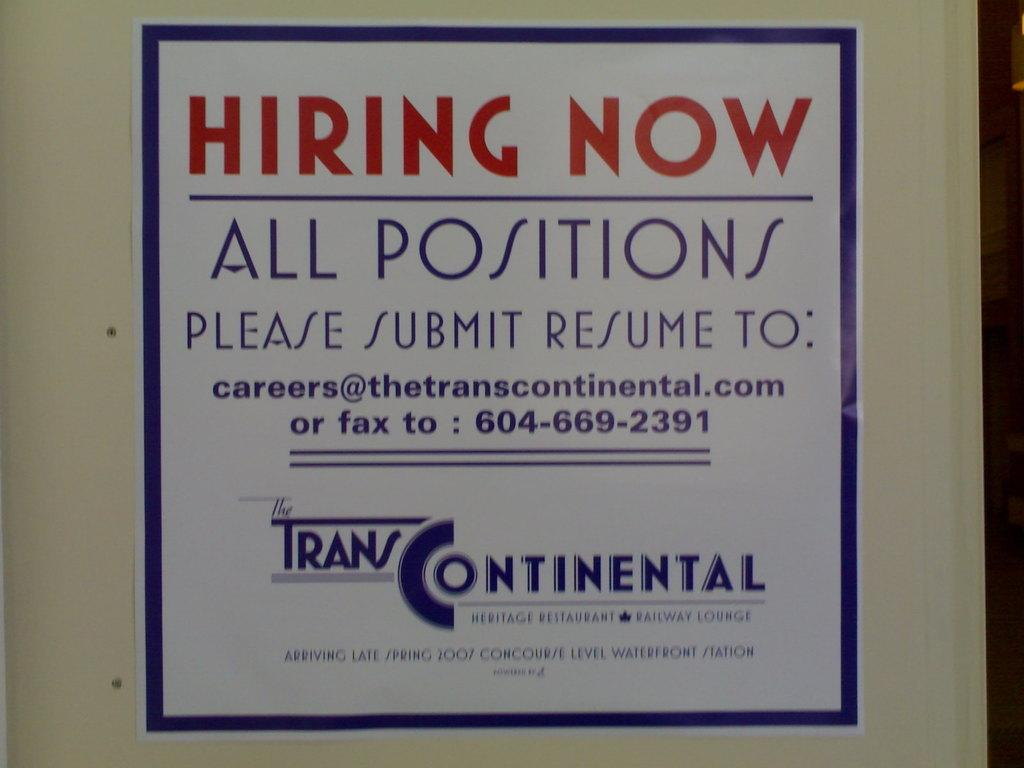<image>
Summarize the visual content of the image. A hiring now sign that says they are hiring for all positions. 